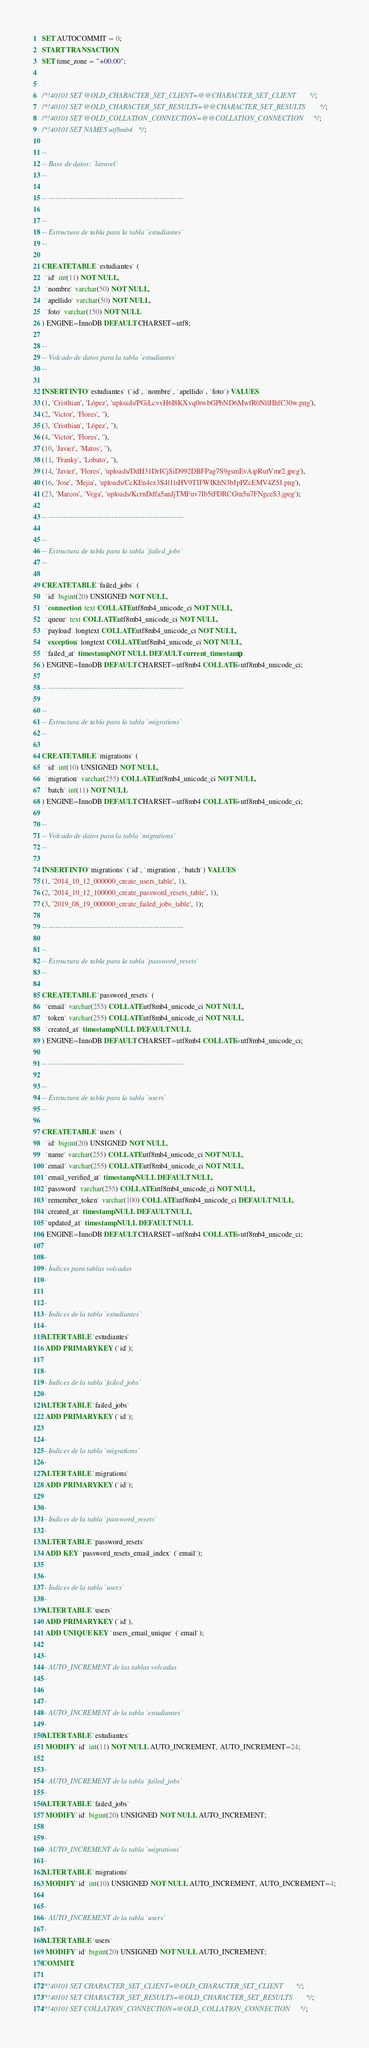Convert code to text. <code><loc_0><loc_0><loc_500><loc_500><_SQL_>SET AUTOCOMMIT = 0;
START TRANSACTION;
SET time_zone = "+00:00";


/*!40101 SET @OLD_CHARACTER_SET_CLIENT=@@CHARACTER_SET_CLIENT */;
/*!40101 SET @OLD_CHARACTER_SET_RESULTS=@@CHARACTER_SET_RESULTS */;
/*!40101 SET @OLD_COLLATION_CONNECTION=@@COLLATION_CONNECTION */;
/*!40101 SET NAMES utf8mb4 */;

--
-- Base de datos: `laravel`
--

-- --------------------------------------------------------

--
-- Estructura de tabla para la tabla `estudiantes`
--

CREATE TABLE `estudiantes` (
  `id` int(11) NOT NULL,
  `nombre` varchar(50) NOT NULL,
  `apellido` varchar(50) NOT NULL,
  `foto` varchar(150) NOT NULL
) ENGINE=InnoDB DEFAULT CHARSET=utf8;

--
-- Volcado de datos para la tabla `estudiantes`
--

INSERT INTO `estudiantes` (`id`, `nombre`, `apellido`, `foto`) VALUES
(1, 'Cristhian', 'López', 'uploads/PGiLcvvH6I8KXvq0rwbGPbND6MwfR0NllHhfC30w.png'),
(2, 'Victor', 'Flores', ''),
(3, 'Cristhian', 'López', ''),
(4, 'Victor', 'Flores', ''),
(10, 'Javier', 'Matos', ''),
(11, 'Franky', 'Lobato', ''),
(14, 'Javier', 'Flores', 'uploads/DdH31DrICjSiD992DBFPag7S9gsmEvAipRutVmr2.jpeg'),
(16, 'Jose', 'Mejia', 'uploads/CcKEn4ex3S4l1lsHV9TIFWIKhN3bJpPZcEMV4Z5J.png'),
(23, 'Marcos', 'Vega', 'uploads/KcrnDdfa5anJjTMFuv7Ib5tFDRCGtn5u7FNgceS3.jpeg');

-- --------------------------------------------------------

--
-- Estructura de tabla para la tabla `failed_jobs`
--

CREATE TABLE `failed_jobs` (
  `id` bigint(20) UNSIGNED NOT NULL,
  `connection` text COLLATE utf8mb4_unicode_ci NOT NULL,
  `queue` text COLLATE utf8mb4_unicode_ci NOT NULL,
  `payload` longtext COLLATE utf8mb4_unicode_ci NOT NULL,
  `exception` longtext COLLATE utf8mb4_unicode_ci NOT NULL,
  `failed_at` timestamp NOT NULL DEFAULT current_timestamp()
) ENGINE=InnoDB DEFAULT CHARSET=utf8mb4 COLLATE=utf8mb4_unicode_ci;

-- --------------------------------------------------------

--
-- Estructura de tabla para la tabla `migrations`
--

CREATE TABLE `migrations` (
  `id` int(10) UNSIGNED NOT NULL,
  `migration` varchar(255) COLLATE utf8mb4_unicode_ci NOT NULL,
  `batch` int(11) NOT NULL
) ENGINE=InnoDB DEFAULT CHARSET=utf8mb4 COLLATE=utf8mb4_unicode_ci;

--
-- Volcado de datos para la tabla `migrations`
--

INSERT INTO `migrations` (`id`, `migration`, `batch`) VALUES
(1, '2014_10_12_000000_create_users_table', 1),
(2, '2014_10_12_100000_create_password_resets_table', 1),
(3, '2019_08_19_000000_create_failed_jobs_table', 1);

-- --------------------------------------------------------

--
-- Estructura de tabla para la tabla `password_resets`
--

CREATE TABLE `password_resets` (
  `email` varchar(255) COLLATE utf8mb4_unicode_ci NOT NULL,
  `token` varchar(255) COLLATE utf8mb4_unicode_ci NOT NULL,
  `created_at` timestamp NULL DEFAULT NULL
) ENGINE=InnoDB DEFAULT CHARSET=utf8mb4 COLLATE=utf8mb4_unicode_ci;

-- --------------------------------------------------------

--
-- Estructura de tabla para la tabla `users`
--

CREATE TABLE `users` (
  `id` bigint(20) UNSIGNED NOT NULL,
  `name` varchar(255) COLLATE utf8mb4_unicode_ci NOT NULL,
  `email` varchar(255) COLLATE utf8mb4_unicode_ci NOT NULL,
  `email_verified_at` timestamp NULL DEFAULT NULL,
  `password` varchar(255) COLLATE utf8mb4_unicode_ci NOT NULL,
  `remember_token` varchar(100) COLLATE utf8mb4_unicode_ci DEFAULT NULL,
  `created_at` timestamp NULL DEFAULT NULL,
  `updated_at` timestamp NULL DEFAULT NULL
) ENGINE=InnoDB DEFAULT CHARSET=utf8mb4 COLLATE=utf8mb4_unicode_ci;

--
-- Índices para tablas volcadas
--

--
-- Indices de la tabla `estudiantes`
--
ALTER TABLE `estudiantes`
  ADD PRIMARY KEY (`id`);

--
-- Indices de la tabla `failed_jobs`
--
ALTER TABLE `failed_jobs`
  ADD PRIMARY KEY (`id`);

--
-- Indices de la tabla `migrations`
--
ALTER TABLE `migrations`
  ADD PRIMARY KEY (`id`);

--
-- Indices de la tabla `password_resets`
--
ALTER TABLE `password_resets`
  ADD KEY `password_resets_email_index` (`email`);

--
-- Indices de la tabla `users`
--
ALTER TABLE `users`
  ADD PRIMARY KEY (`id`),
  ADD UNIQUE KEY `users_email_unique` (`email`);

--
-- AUTO_INCREMENT de las tablas volcadas
--

--
-- AUTO_INCREMENT de la tabla `estudiantes`
--
ALTER TABLE `estudiantes`
  MODIFY `id` int(11) NOT NULL AUTO_INCREMENT, AUTO_INCREMENT=24;

--
-- AUTO_INCREMENT de la tabla `failed_jobs`
--
ALTER TABLE `failed_jobs`
  MODIFY `id` bigint(20) UNSIGNED NOT NULL AUTO_INCREMENT;

--
-- AUTO_INCREMENT de la tabla `migrations`
--
ALTER TABLE `migrations`
  MODIFY `id` int(10) UNSIGNED NOT NULL AUTO_INCREMENT, AUTO_INCREMENT=4;

--
-- AUTO_INCREMENT de la tabla `users`
--
ALTER TABLE `users`
  MODIFY `id` bigint(20) UNSIGNED NOT NULL AUTO_INCREMENT;
COMMIT;

/*!40101 SET CHARACTER_SET_CLIENT=@OLD_CHARACTER_SET_CLIENT */;
/*!40101 SET CHARACTER_SET_RESULTS=@OLD_CHARACTER_SET_RESULTS */;
/*!40101 SET COLLATION_CONNECTION=@OLD_COLLATION_CONNECTION */;
</code> 